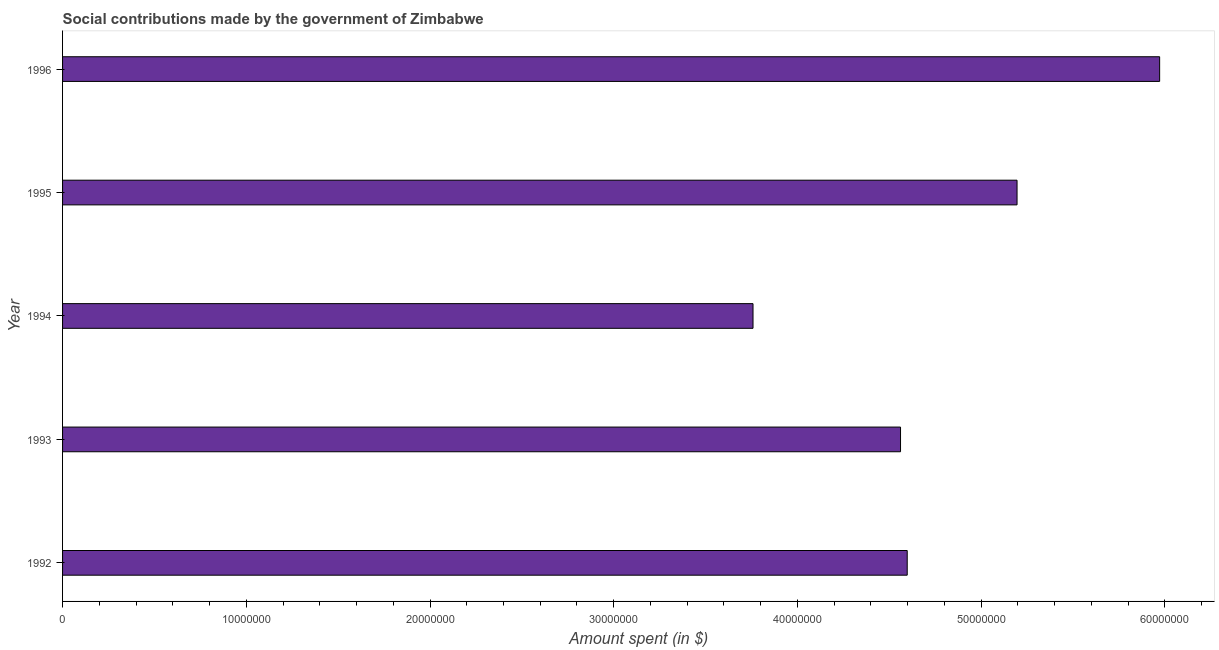Does the graph contain any zero values?
Your response must be concise. No. What is the title of the graph?
Your response must be concise. Social contributions made by the government of Zimbabwe. What is the label or title of the X-axis?
Ensure brevity in your answer.  Amount spent (in $). What is the label or title of the Y-axis?
Give a very brief answer. Year. What is the amount spent in making social contributions in 1995?
Make the answer very short. 5.20e+07. Across all years, what is the maximum amount spent in making social contributions?
Keep it short and to the point. 5.97e+07. Across all years, what is the minimum amount spent in making social contributions?
Give a very brief answer. 3.76e+07. In which year was the amount spent in making social contributions minimum?
Keep it short and to the point. 1994. What is the sum of the amount spent in making social contributions?
Keep it short and to the point. 2.41e+08. What is the difference between the amount spent in making social contributions in 1992 and 1994?
Provide a short and direct response. 8.39e+06. What is the average amount spent in making social contributions per year?
Keep it short and to the point. 4.82e+07. What is the median amount spent in making social contributions?
Make the answer very short. 4.60e+07. What is the ratio of the amount spent in making social contributions in 1992 to that in 1993?
Your answer should be compact. 1.01. Is the amount spent in making social contributions in 1993 less than that in 1994?
Your answer should be very brief. No. Is the difference between the amount spent in making social contributions in 1993 and 1995 greater than the difference between any two years?
Make the answer very short. No. What is the difference between the highest and the second highest amount spent in making social contributions?
Offer a very short reply. 7.76e+06. What is the difference between the highest and the lowest amount spent in making social contributions?
Provide a succinct answer. 2.21e+07. In how many years, is the amount spent in making social contributions greater than the average amount spent in making social contributions taken over all years?
Your answer should be compact. 2. Are all the bars in the graph horizontal?
Provide a short and direct response. Yes. What is the difference between two consecutive major ticks on the X-axis?
Give a very brief answer. 1.00e+07. Are the values on the major ticks of X-axis written in scientific E-notation?
Provide a succinct answer. No. What is the Amount spent (in $) in 1992?
Make the answer very short. 4.60e+07. What is the Amount spent (in $) in 1993?
Your response must be concise. 4.56e+07. What is the Amount spent (in $) of 1994?
Offer a terse response. 3.76e+07. What is the Amount spent (in $) of 1995?
Offer a terse response. 5.20e+07. What is the Amount spent (in $) in 1996?
Your answer should be very brief. 5.97e+07. What is the difference between the Amount spent (in $) in 1992 and 1993?
Ensure brevity in your answer.  3.64e+05. What is the difference between the Amount spent (in $) in 1992 and 1994?
Your answer should be compact. 8.39e+06. What is the difference between the Amount spent (in $) in 1992 and 1995?
Your answer should be compact. -5.98e+06. What is the difference between the Amount spent (in $) in 1992 and 1996?
Keep it short and to the point. -1.37e+07. What is the difference between the Amount spent (in $) in 1993 and 1994?
Make the answer very short. 8.03e+06. What is the difference between the Amount spent (in $) in 1993 and 1995?
Keep it short and to the point. -6.34e+06. What is the difference between the Amount spent (in $) in 1993 and 1996?
Make the answer very short. -1.41e+07. What is the difference between the Amount spent (in $) in 1994 and 1995?
Give a very brief answer. -1.44e+07. What is the difference between the Amount spent (in $) in 1994 and 1996?
Offer a terse response. -2.21e+07. What is the difference between the Amount spent (in $) in 1995 and 1996?
Keep it short and to the point. -7.76e+06. What is the ratio of the Amount spent (in $) in 1992 to that in 1993?
Provide a short and direct response. 1.01. What is the ratio of the Amount spent (in $) in 1992 to that in 1994?
Ensure brevity in your answer.  1.22. What is the ratio of the Amount spent (in $) in 1992 to that in 1995?
Your answer should be compact. 0.89. What is the ratio of the Amount spent (in $) in 1992 to that in 1996?
Ensure brevity in your answer.  0.77. What is the ratio of the Amount spent (in $) in 1993 to that in 1994?
Ensure brevity in your answer.  1.21. What is the ratio of the Amount spent (in $) in 1993 to that in 1995?
Make the answer very short. 0.88. What is the ratio of the Amount spent (in $) in 1993 to that in 1996?
Your answer should be compact. 0.76. What is the ratio of the Amount spent (in $) in 1994 to that in 1995?
Your answer should be compact. 0.72. What is the ratio of the Amount spent (in $) in 1994 to that in 1996?
Offer a very short reply. 0.63. What is the ratio of the Amount spent (in $) in 1995 to that in 1996?
Give a very brief answer. 0.87. 